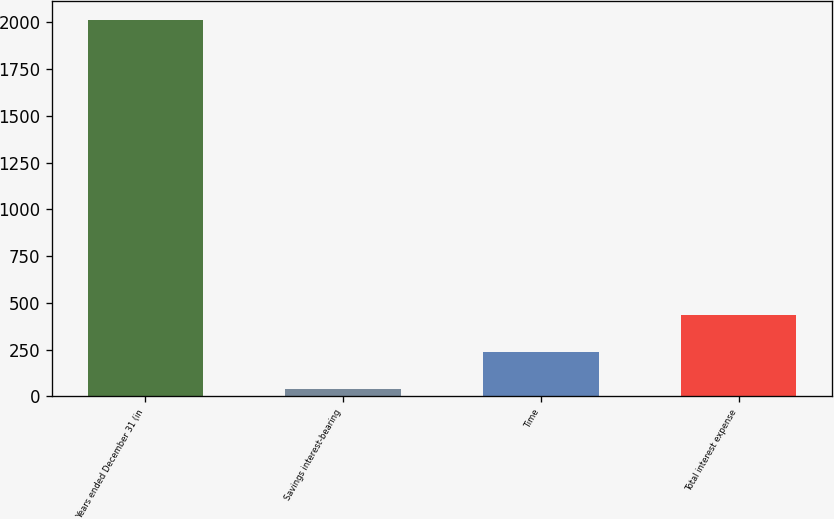<chart> <loc_0><loc_0><loc_500><loc_500><bar_chart><fcel>Years ended December 31 (in<fcel>Savings interest-bearing<fcel>Time<fcel>Total interest expense<nl><fcel>2012<fcel>38.7<fcel>236.03<fcel>433.36<nl></chart> 